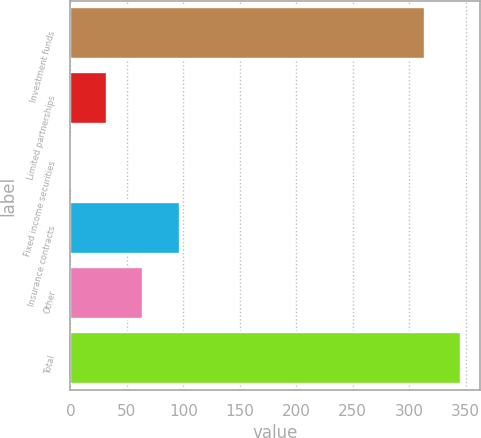<chart> <loc_0><loc_0><loc_500><loc_500><bar_chart><fcel>Investment funds<fcel>Limited partnerships<fcel>Fixed income securities<fcel>Insurance contracts<fcel>Other<fcel>Total<nl><fcel>313.6<fcel>32.44<fcel>0.3<fcel>96.72<fcel>64.58<fcel>345.74<nl></chart> 